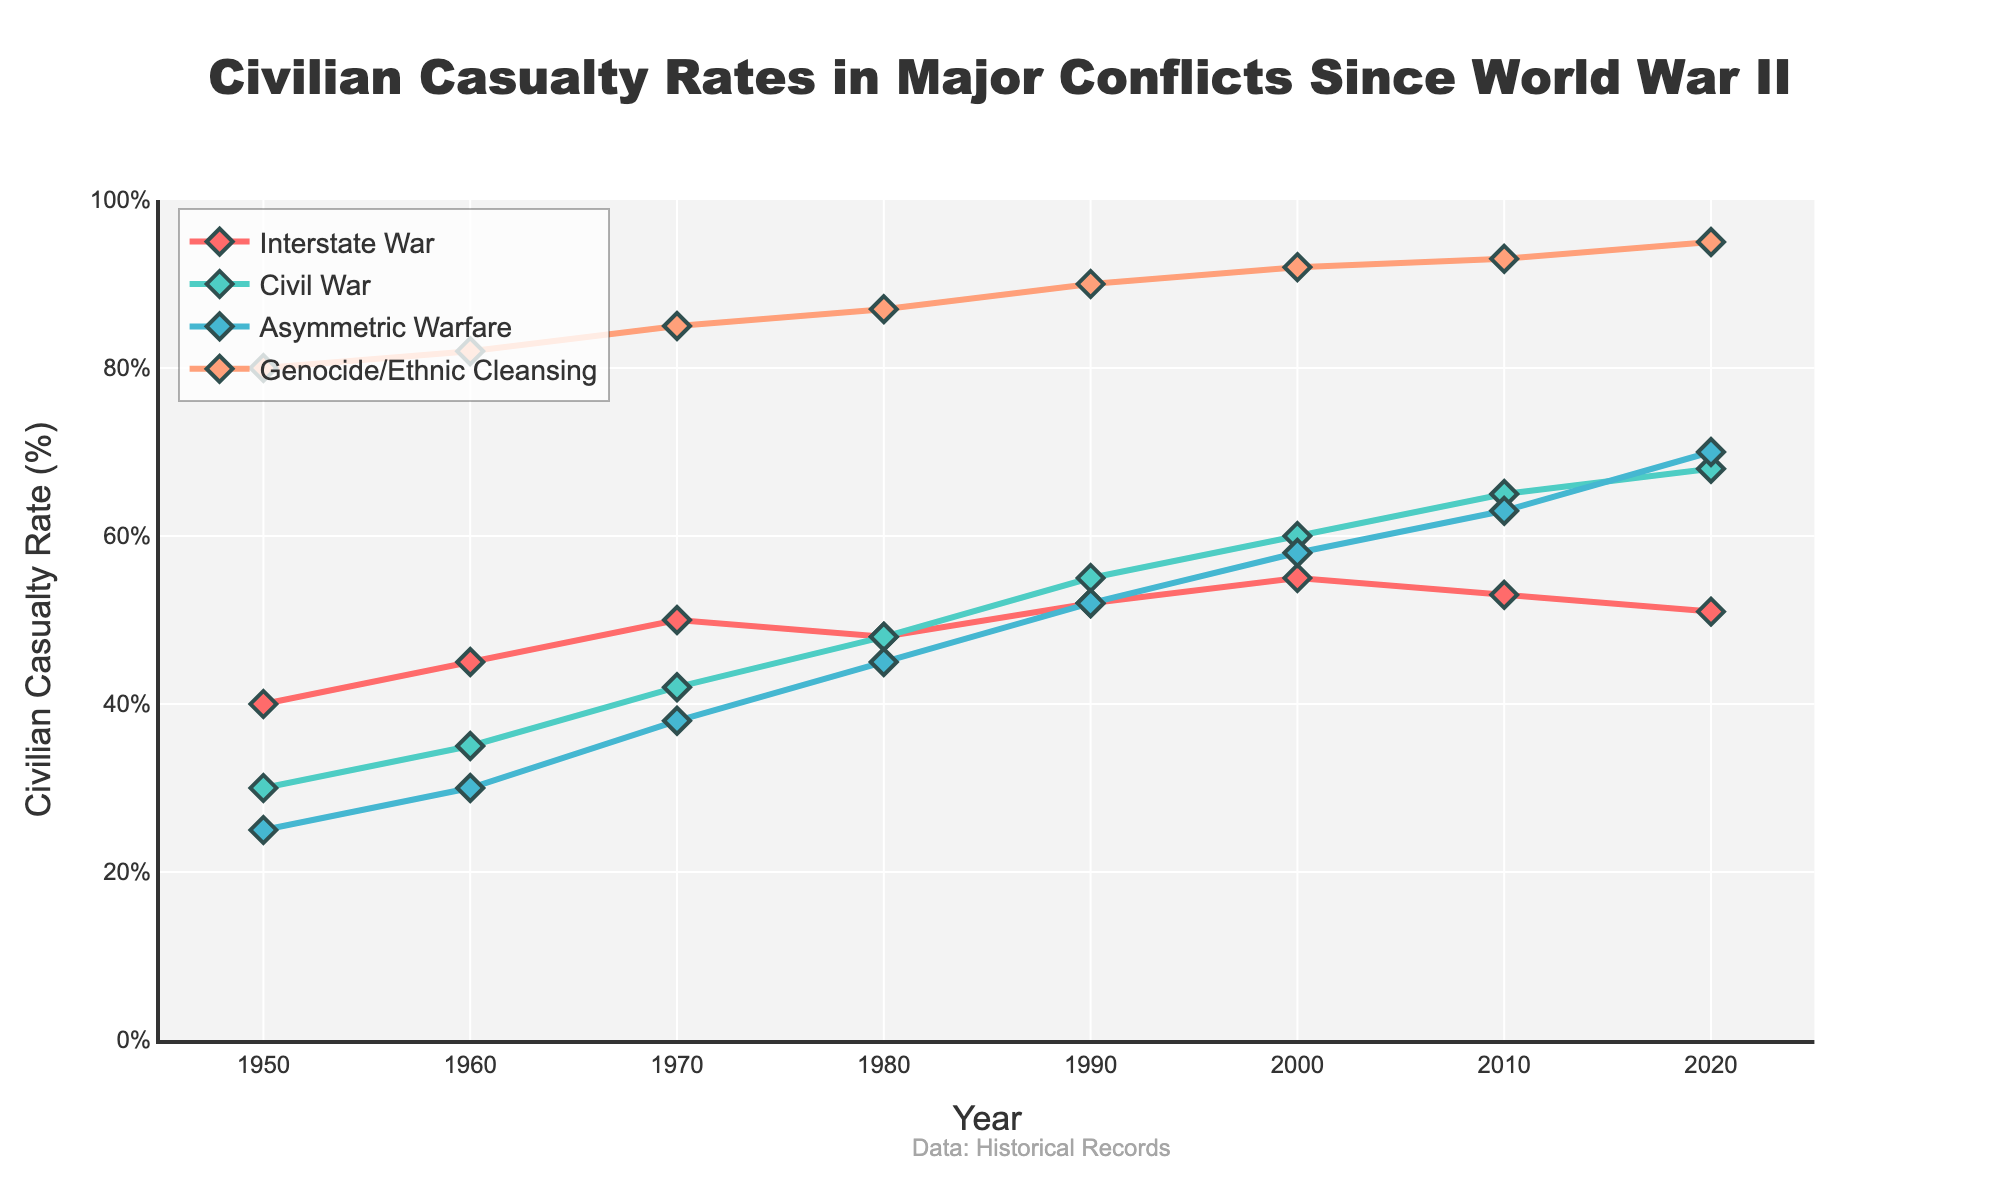what is the trend of civilian casualty rates for Interstate Wars from 1950 to 2020? Looking at the series of points connected by a line representing Interstate Wars, the trend shows a general increase from 1950 to around 2000, peaking at 55%, then a slight decrease through 2020 where the rate is around 51%.
Answer: Increase, then slight decrease Which conflict type had the highest civilian casualty rate in 1950? By comparing the starting points of each line on the chart for the year 1950, Genocide/Ethnic Cleansing has the highest starting point at 80%.
Answer: Genocide/Ethnic Cleansing What is the difference in civilian casualty rates between Civil War and Asymmetric Warfare in 2020? The civilian casualty rate for Civil War in 2020 is 68%, and for Asymmetric Warfare it is 70%. The difference is 70% - 68% which is 2%.
Answer: 2% How did the civilian casualty rate of Civil War change from 1980 to 1990? Observing the line representing Civil War, the rate in 1980 is 48% and in 1990 it increases to 55%. The rate increased by 55% - 48% which is 7%.
Answer: Increased by 7% In which year did the civilian casualty rate of Asymmetric Warfare surpass Civil War for the first time? Checking the intersecting lines for Asymmetric Warfare and Civil War, Asymmetric Warfare surpasses Civil War somewhere between 2000 and 2010. By 2010, Asymmetric Warfare has a higher value of 63% compared to Civil War's 65%, hence it is in 2010.
Answer: 2010 What is the average civilian casualty rate of Interstate Wars from 1950 to 2020? Calculating the average for Interstate War over the years 1950 (40%), 1960 (45%), 1970 (50%), 1980 (48%), 1990 (52%), 2000 (55%), 2010 (53%), 2020 (51%) gives (40+45+50+48+52+55+53+51)/8 = 49.25%.
Answer: 49.25% Which conflict type has the smallest increase in civilian casualty rates from 1950 to 2020? Checking the vertical differences for each line, Interstate War increases from 40% to 51%, Civil War from 30% to 68%, Asymmetric Warfare from 25% to 70%, and Genocide/Ethnic Cleansing from 80% to 95%. The smallest increase is for Interstate War, which is 51% - 40% = 11%.
Answer: Interstate War By how much did the civilian casualty rate of Genocide/Ethnic Cleansing increase between 1950 and 2010? Noting the points for these years, in 1950 Genocide/Ethnic Cleansing is at 80%, and by 2010 it reaches 93%. The increase is 93% - 80% = 13%.
Answer: 13% Which conflict type shows a steady rise in civilian casualty rates across all decades from 1950 to 2020? Observing the pattern of the lines, Asymmetric Warfare shows a consistent, steady increase in casualty rates from 25% in 1950 to 70% in 2020 across all decades.
Answer: Asymmetric Warfare Between 2000 and 2010, which conflict type had the sharpest increase in civilian casualty rates? Comparing the slope of the lines between 2000 and 2010, Civil War increases from 60% to 65% (5%), Asymmetric Warfare from 58% to 63% (5%), Interstate War decreases from 55% to 53% (-2%), and Genocide/Ethnic Cleansing increases from 92% to 93% (1%). Civil War and Asymmetric Warfare have the steepest increase of 5%.
Answer: Civil War, Asymmetric Warfare 